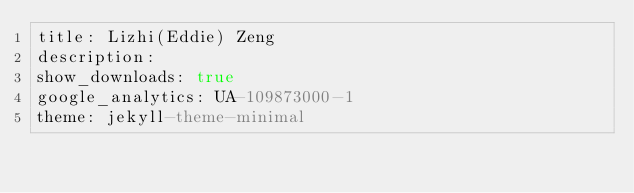Convert code to text. <code><loc_0><loc_0><loc_500><loc_500><_YAML_>title: Lizhi(Eddie) Zeng
description:
show_downloads: true
google_analytics: UA-109873000-1
theme: jekyll-theme-minimal</code> 